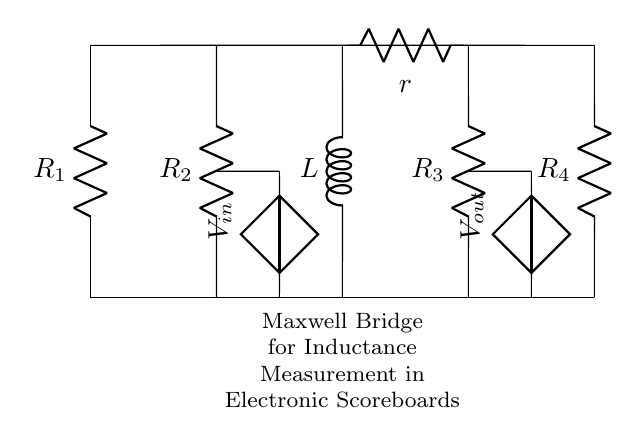What is the purpose of the Maxwell bridge in this circuit? The Maxwell bridge is used for measuring inductance by creating a balanced circuit condition, allowing precise inductance values to be calculated based on resistance values.
Answer: Measuring inductance What is the total number of resistors in this circuit? The circuit diagram contains four resistors labeled R1, R2, R3, and R4. Counting these provides the total.
Answer: Four What type of component is used to measure inductance? The inductance is measured by the inductor component labeled L in the circuit. It is specifically designed to store energy in a magnetic field.
Answer: Inductor What is the relationship between R1, R2, R3, and R4 for balance? For the bridge to be balanced, the ratio of R1 to R2 must equal the ratio of R3 to the inductive reactance of L (including resistance r). This creates a condition where no current flows through the detection part of the circuit.
Answer: R1/R2 = R3/X What voltage is applied to the input of the Maxwell bridge? The input voltage is represented by the source labeled Vin in the circuit diagram. This source provides the necessary voltage to establish current flow and measure induction through the bridge.
Answer: Vin What role does the resistor r play in the circuit? The resistor r is in series with the inductor L and serves to account for any losses or reactance in the inductor, helping to achieve a more accurate measurement of inductance when the bridge is balanced.
Answer: Losses 